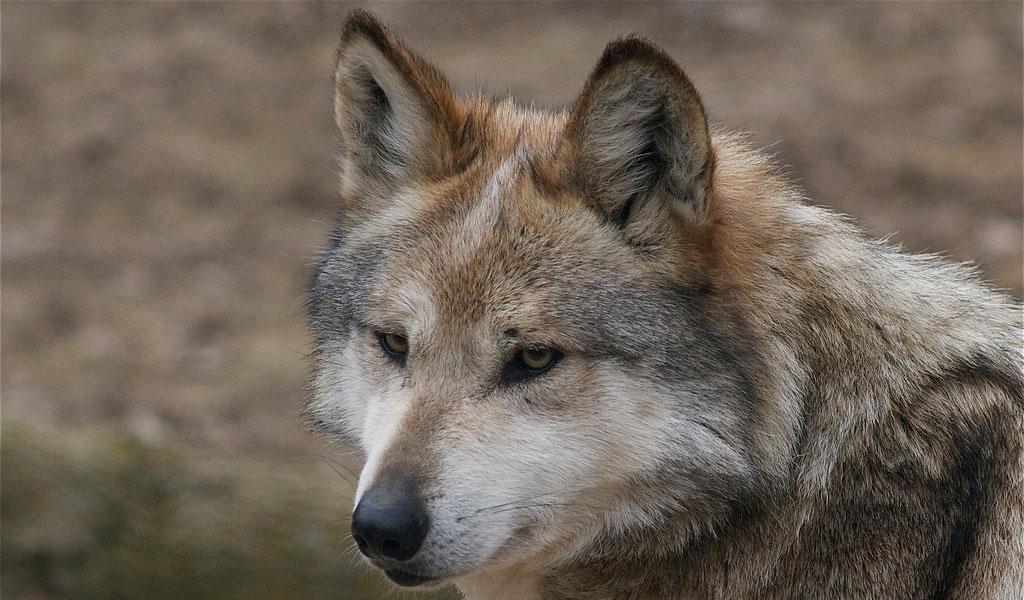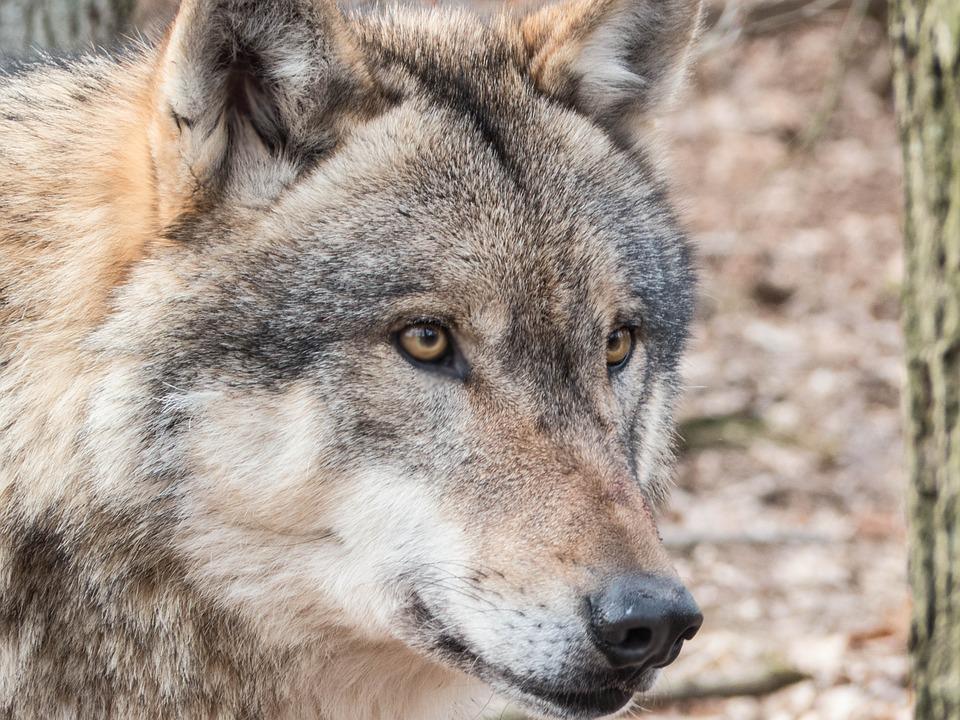The first image is the image on the left, the second image is the image on the right. Given the left and right images, does the statement "At least one of the animals is walking in the snow." hold true? Answer yes or no. No. The first image is the image on the left, the second image is the image on the right. Examine the images to the left and right. Is the description "At least one image shows a wolf in a snowy scene." accurate? Answer yes or no. No. 